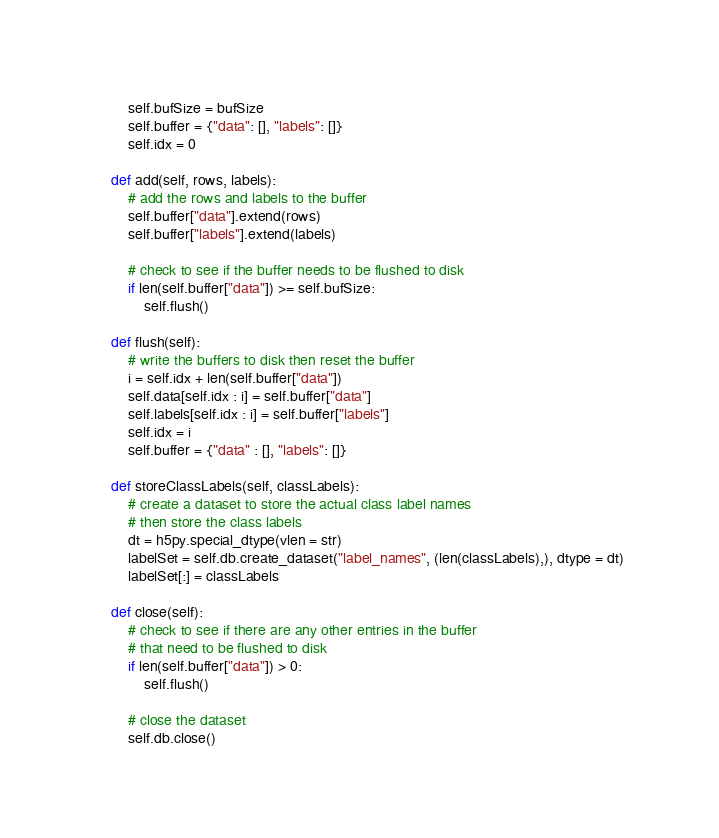Convert code to text. <code><loc_0><loc_0><loc_500><loc_500><_Python_>        self.bufSize = bufSize
        self.buffer = {"data": [], "labels": []}
        self.idx = 0

    def add(self, rows, labels):
        # add the rows and labels to the buffer
        self.buffer["data"].extend(rows)
        self.buffer["labels"].extend(labels)

        # check to see if the buffer needs to be flushed to disk
        if len(self.buffer["data"]) >= self.bufSize:
            self.flush()

    def flush(self):
        # write the buffers to disk then reset the buffer
        i = self.idx + len(self.buffer["data"])
        self.data[self.idx : i] = self.buffer["data"]
        self.labels[self.idx : i] = self.buffer["labels"]
        self.idx = i
        self.buffer = {"data" : [], "labels": []}

    def storeClassLabels(self, classLabels):
        # create a dataset to store the actual class label names
        # then store the class labels
        dt = h5py.special_dtype(vlen = str)
        labelSet = self.db.create_dataset("label_names", (len(classLabels),), dtype = dt)
        labelSet[:] = classLabels

    def close(self):
        # check to see if there are any other entries in the buffer
        # that need to be flushed to disk
        if len(self.buffer["data"]) > 0:
            self.flush()

        # close the dataset
        self.db.close()
</code> 